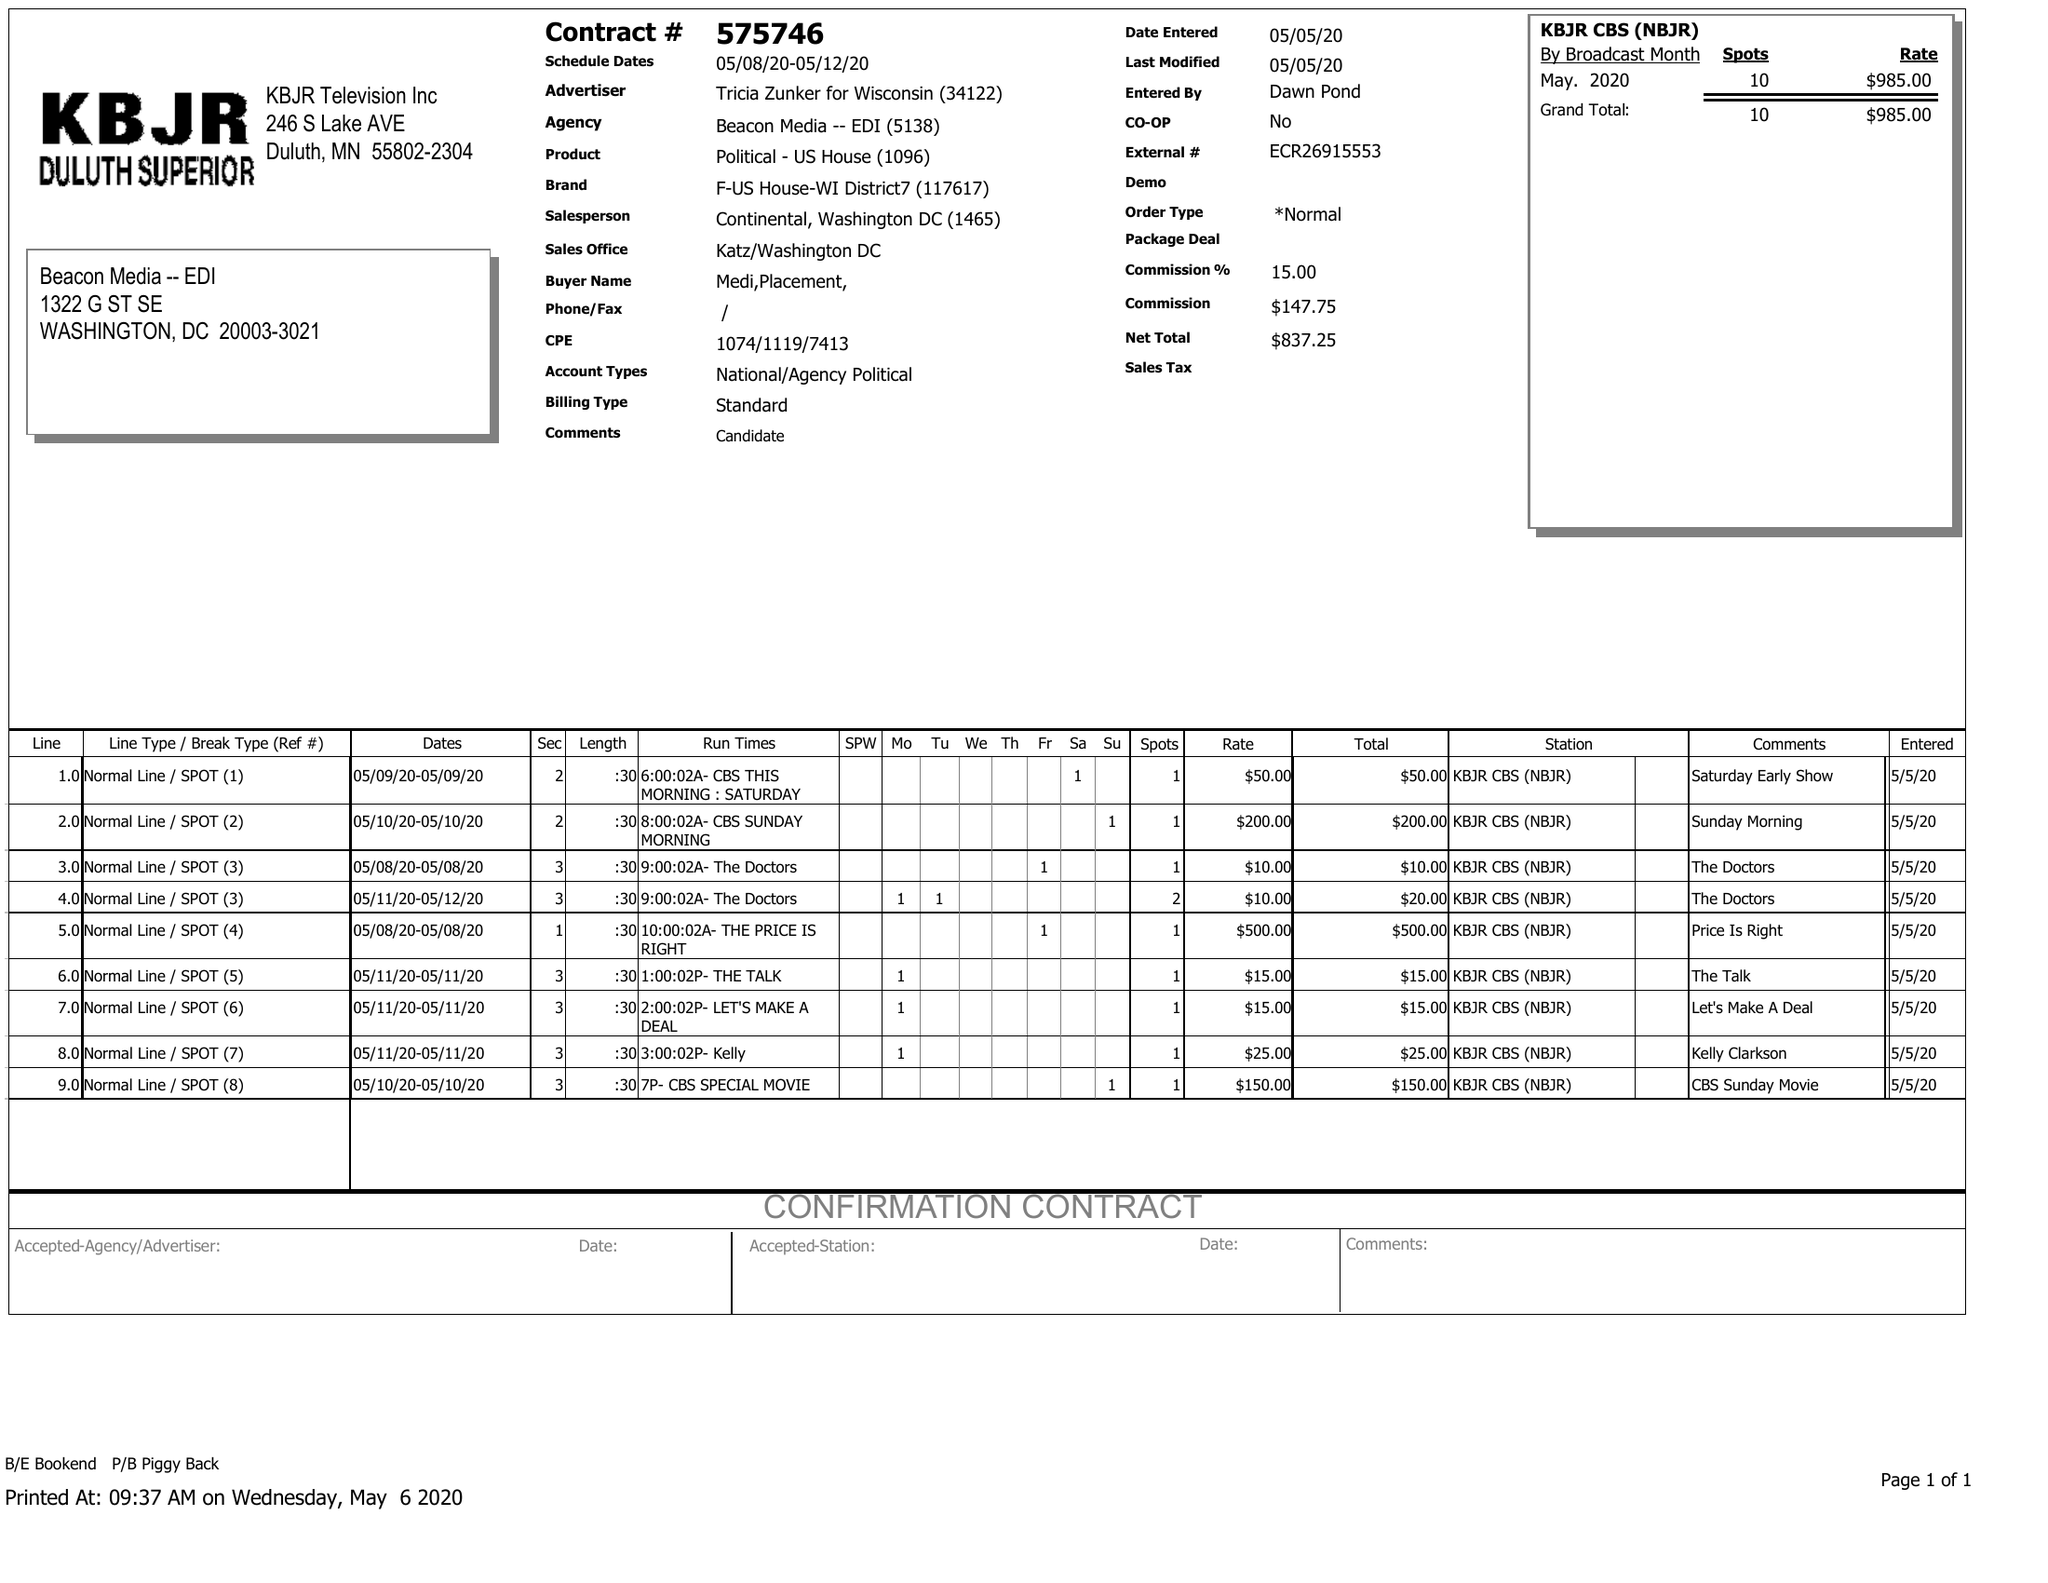What is the value for the contract_num?
Answer the question using a single word or phrase. 575746 